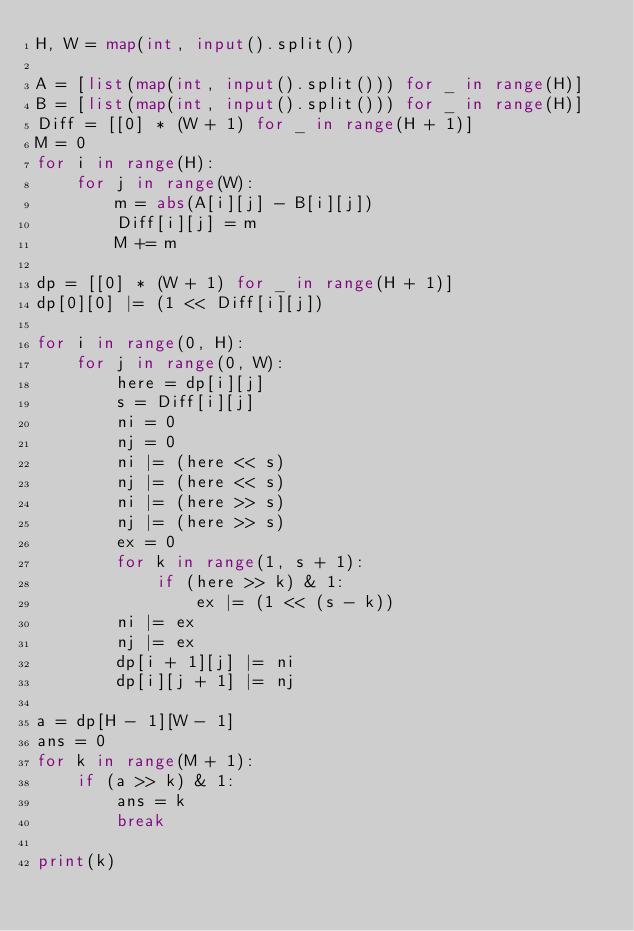<code> <loc_0><loc_0><loc_500><loc_500><_Python_>H, W = map(int, input().split())

A = [list(map(int, input().split())) for _ in range(H)]
B = [list(map(int, input().split())) for _ in range(H)]
Diff = [[0] * (W + 1) for _ in range(H + 1)]
M = 0
for i in range(H):
    for j in range(W):
        m = abs(A[i][j] - B[i][j])
        Diff[i][j] = m
        M += m

dp = [[0] * (W + 1) for _ in range(H + 1)]
dp[0][0] |= (1 << Diff[i][j])

for i in range(0, H):
    for j in range(0, W):
        here = dp[i][j]
        s = Diff[i][j]
        ni = 0
        nj = 0
        ni |= (here << s)
        nj |= (here << s)
        ni |= (here >> s)
        nj |= (here >> s)
        ex = 0
        for k in range(1, s + 1):
            if (here >> k) & 1:
                ex |= (1 << (s - k))
        ni |= ex
        nj |= ex
        dp[i + 1][j] |= ni
        dp[i][j + 1] |= nj

a = dp[H - 1][W - 1]
ans = 0
for k in range(M + 1):
    if (a >> k) & 1:
        ans = k
        break

print(k)
</code> 